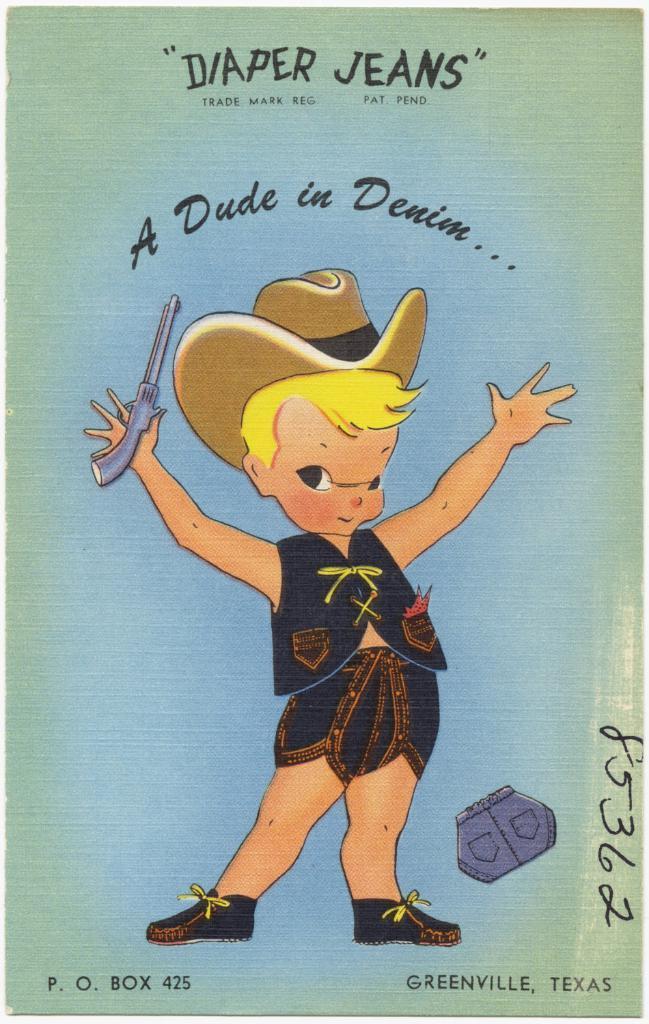How would you summarize this image in a sentence or two? In this picture we can see a cartoon poster, we can see a cartoon of a person and some text here. 